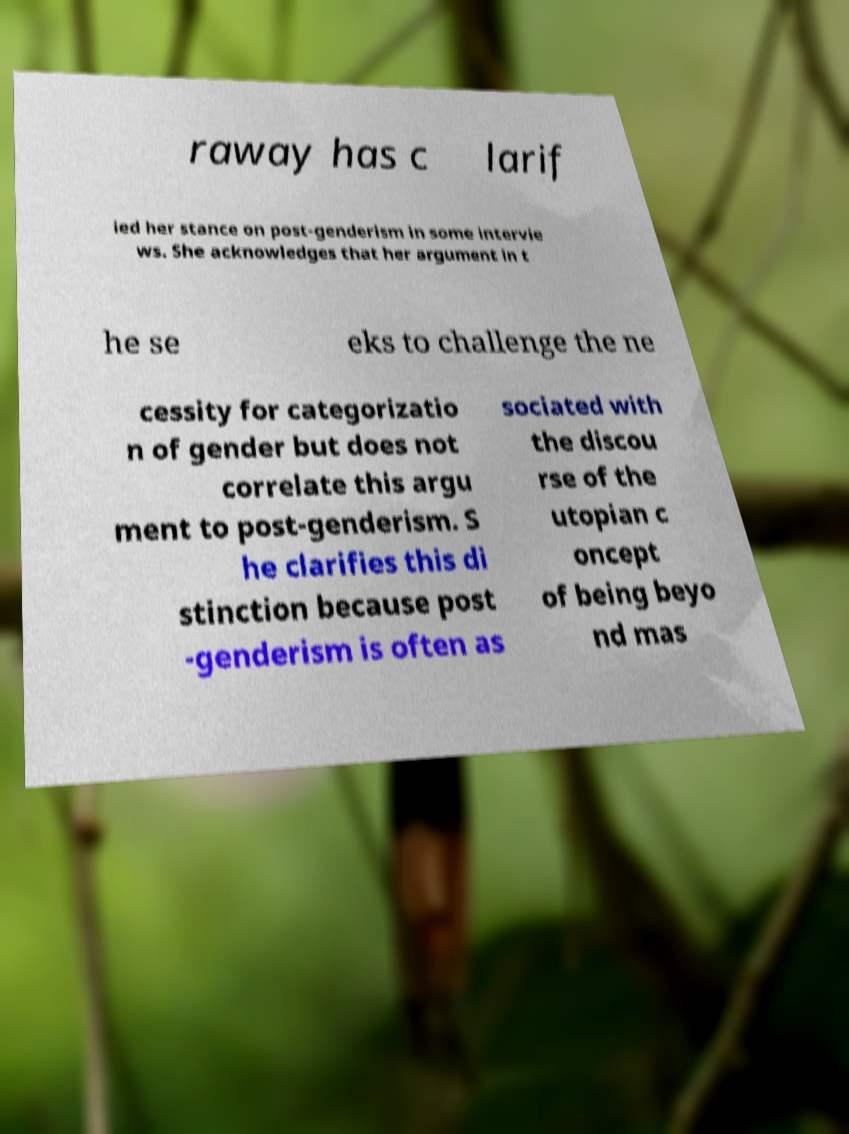I need the written content from this picture converted into text. Can you do that? raway has c larif ied her stance on post-genderism in some intervie ws. She acknowledges that her argument in t he se eks to challenge the ne cessity for categorizatio n of gender but does not correlate this argu ment to post-genderism. S he clarifies this di stinction because post -genderism is often as sociated with the discou rse of the utopian c oncept of being beyo nd mas 